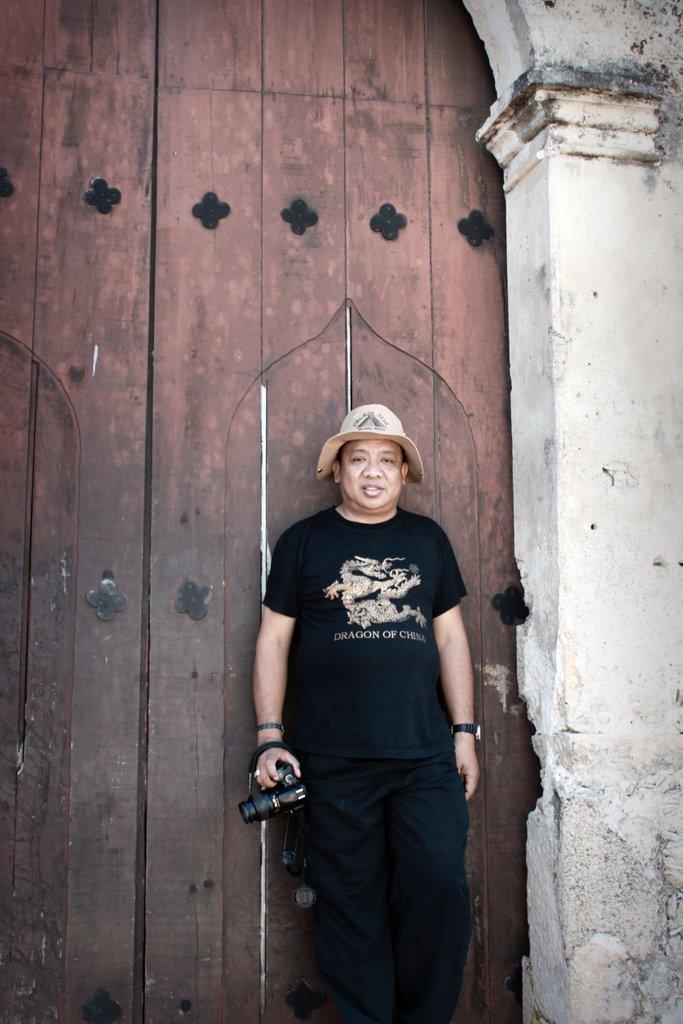Describe this image in one or two sentences. Here I can see a man wearing a black color dress, cap on the head, holding camera in the hand, standing and leaning to the gate which is made up of wood. On the right side, I can see the wall. 